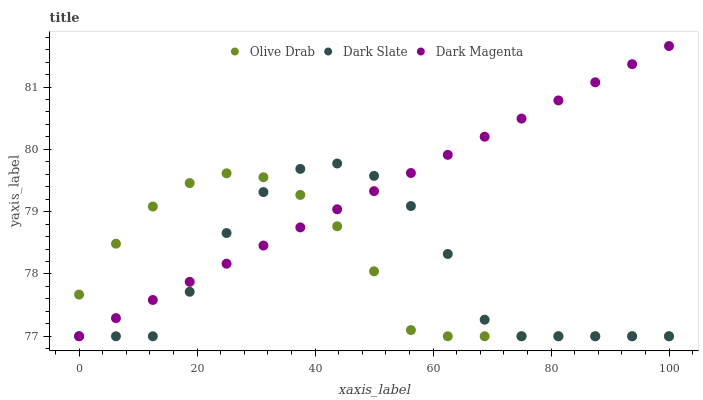Does Dark Slate have the minimum area under the curve?
Answer yes or no. Yes. Does Dark Magenta have the maximum area under the curve?
Answer yes or no. Yes. Does Olive Drab have the minimum area under the curve?
Answer yes or no. No. Does Olive Drab have the maximum area under the curve?
Answer yes or no. No. Is Dark Magenta the smoothest?
Answer yes or no. Yes. Is Dark Slate the roughest?
Answer yes or no. Yes. Is Olive Drab the smoothest?
Answer yes or no. No. Is Olive Drab the roughest?
Answer yes or no. No. Does Dark Slate have the lowest value?
Answer yes or no. Yes. Does Dark Magenta have the highest value?
Answer yes or no. Yes. Does Olive Drab have the highest value?
Answer yes or no. No. Does Olive Drab intersect Dark Magenta?
Answer yes or no. Yes. Is Olive Drab less than Dark Magenta?
Answer yes or no. No. Is Olive Drab greater than Dark Magenta?
Answer yes or no. No. 